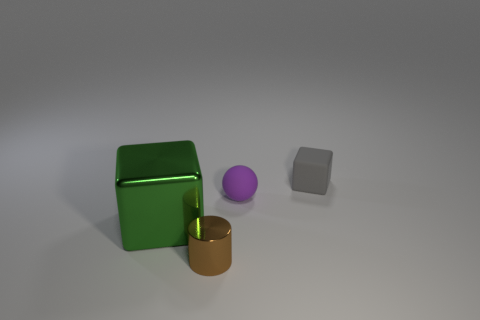Is there any indication of what time of day it might be? The image does not provide any direct indication of the time of day as it appears to be an indoor scene with uniform lighting. There are no windows or sources of natural light visible, and the shadows cast by the objects are soft and diffused, suggesting an artificial light source above and possibly around the scene. 